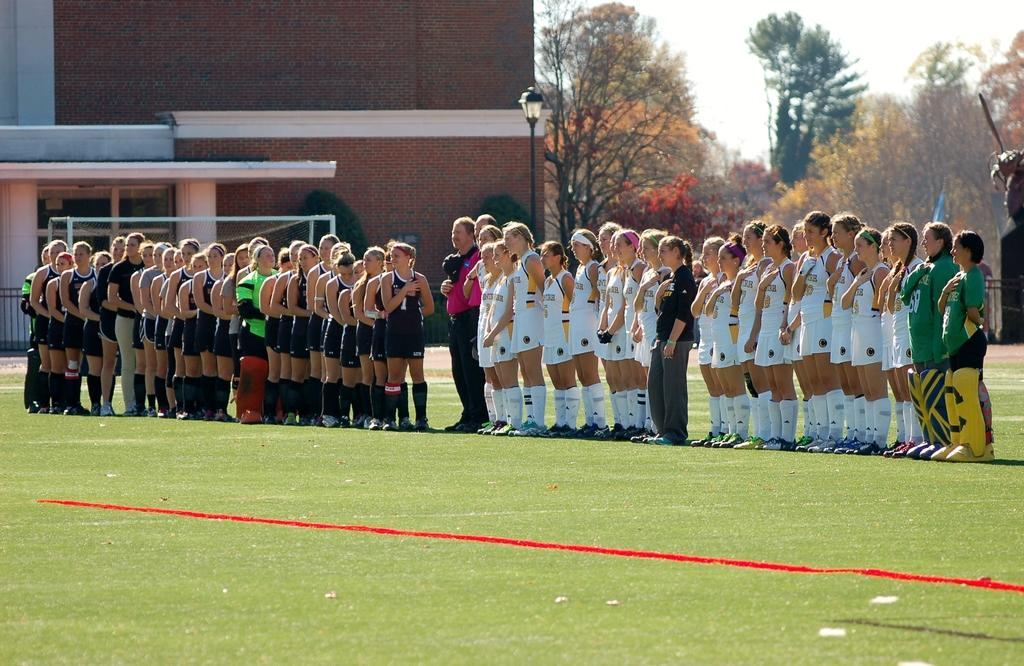How many people are in the image? There is a group of people in the image, but the exact number is not specified. Where are the people standing in the image? The people are standing on the grass in the image. What can be seen in the background of the image? There is a building, trees, and the sky visible in the background of the image. What is the purpose of the pole in the image? The pole might be supporting the light or the football net in the image. What is the light used for in the image? The light might be used for illuminating the area or the football net in the image. What is the governor doing in the image? There is no mention of a governor or any political figure in the image. The image features a group of people, a football net, a light, a pole, a building, trees, grass, and the sky. 